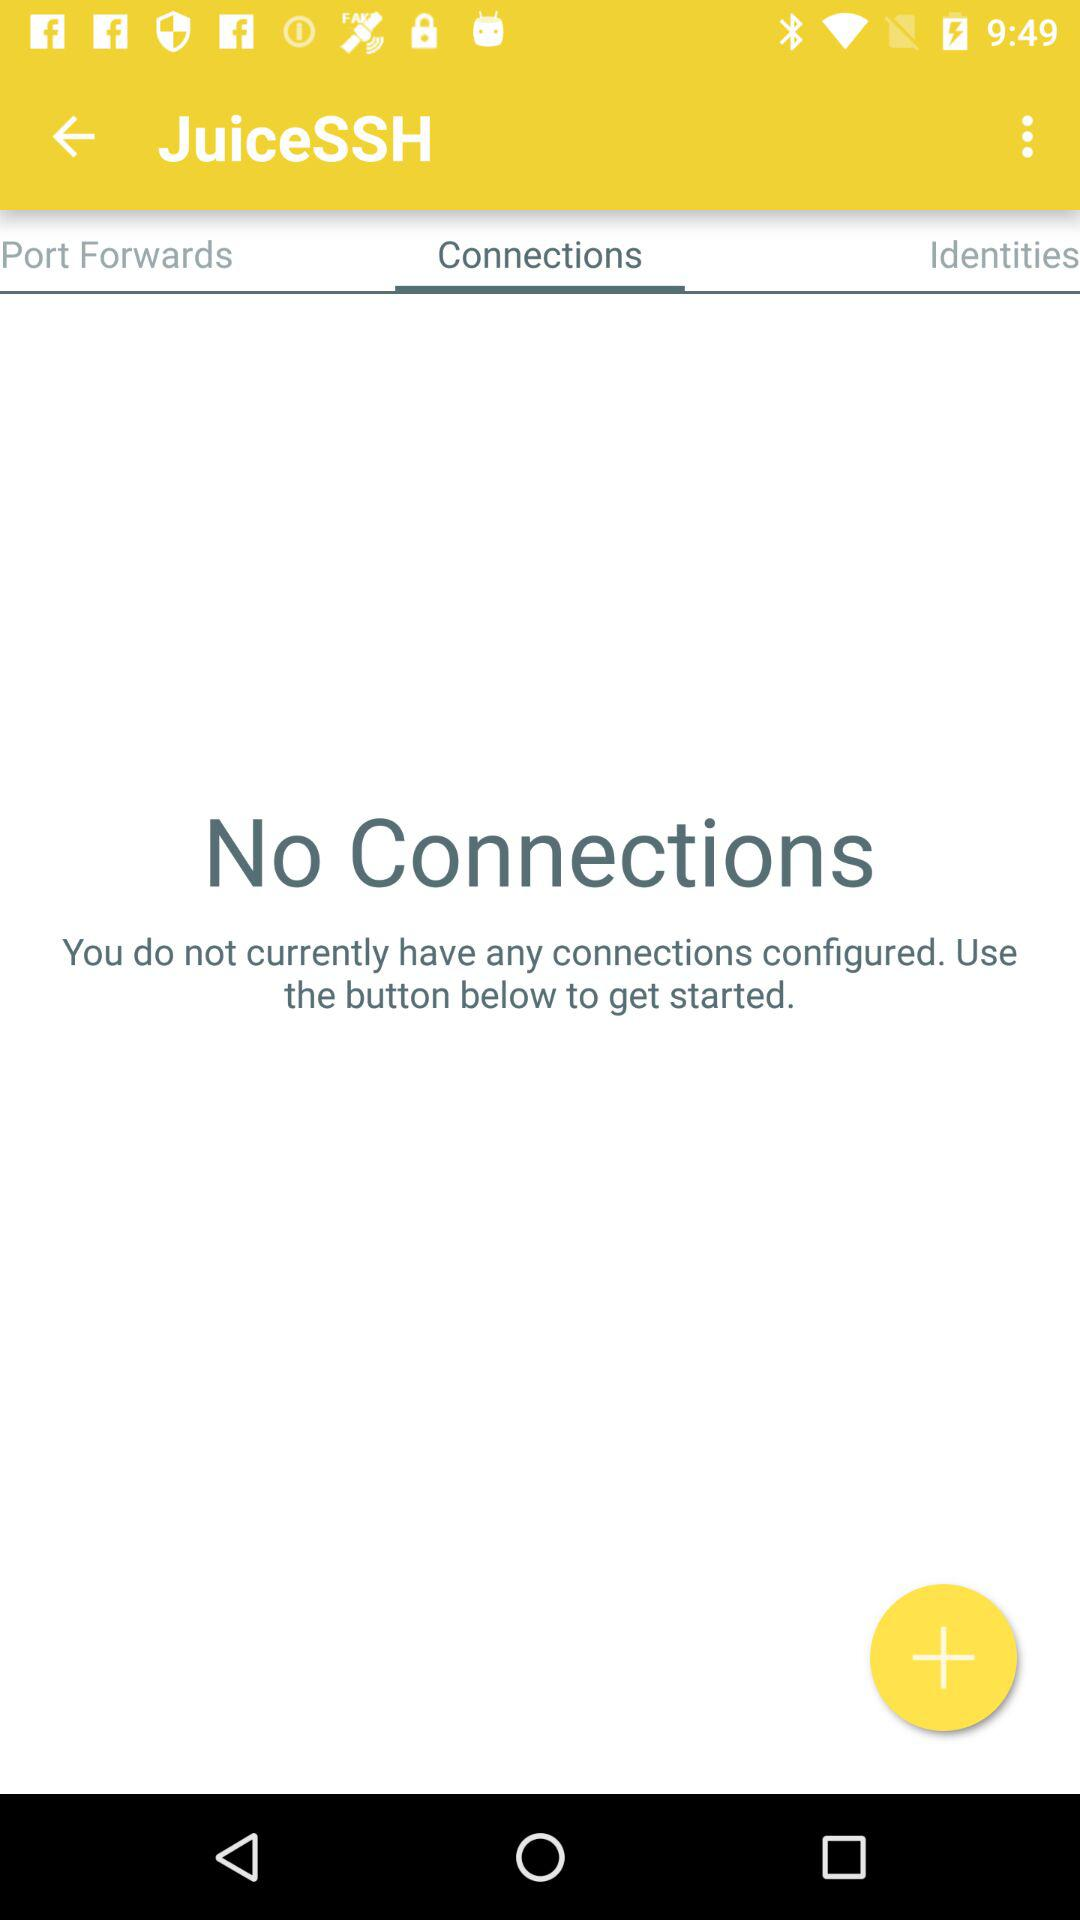Which tab am I using? You are using the Connections tab. 